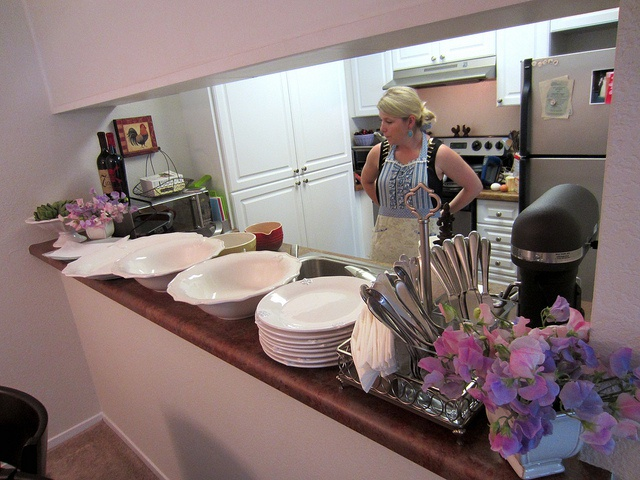Describe the objects in this image and their specific colors. I can see potted plant in gray, purple, and black tones, refrigerator in gray, darkgray, and black tones, people in gray and darkgray tones, bowl in gray, tan, lightgray, and brown tones, and chair in gray and black tones in this image. 